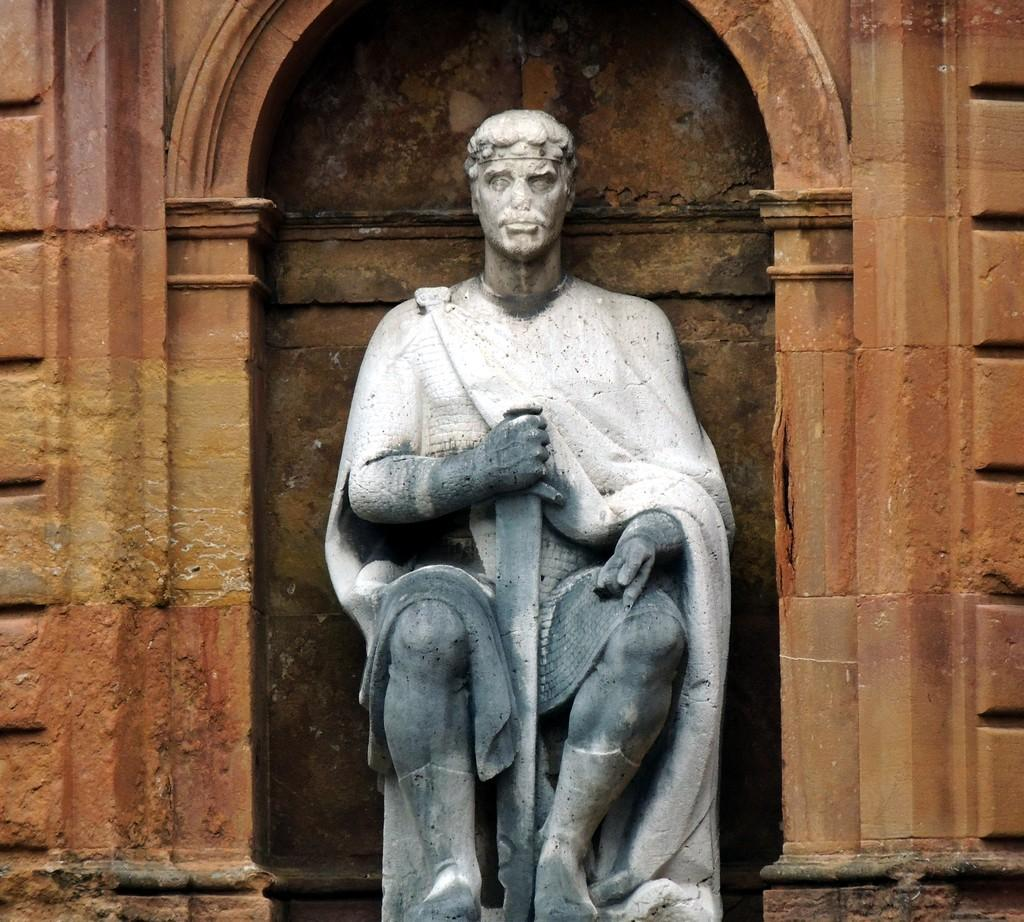What is the main subject of the image? There is a statue of a man in the image. What is the statue doing? The statue is sitting. Where is the statue located in the image? The statue is in the front of the image. What can be seen in the background of the image? There is a brown arch wall in the background of the image. How many snails are crawling on the statue in the image? There are no snails present in the image; it features a statue of a man sitting. What type of giants can be seen interacting with the statue in the image? There are no giants present in the image; it features a statue of a man sitting. 